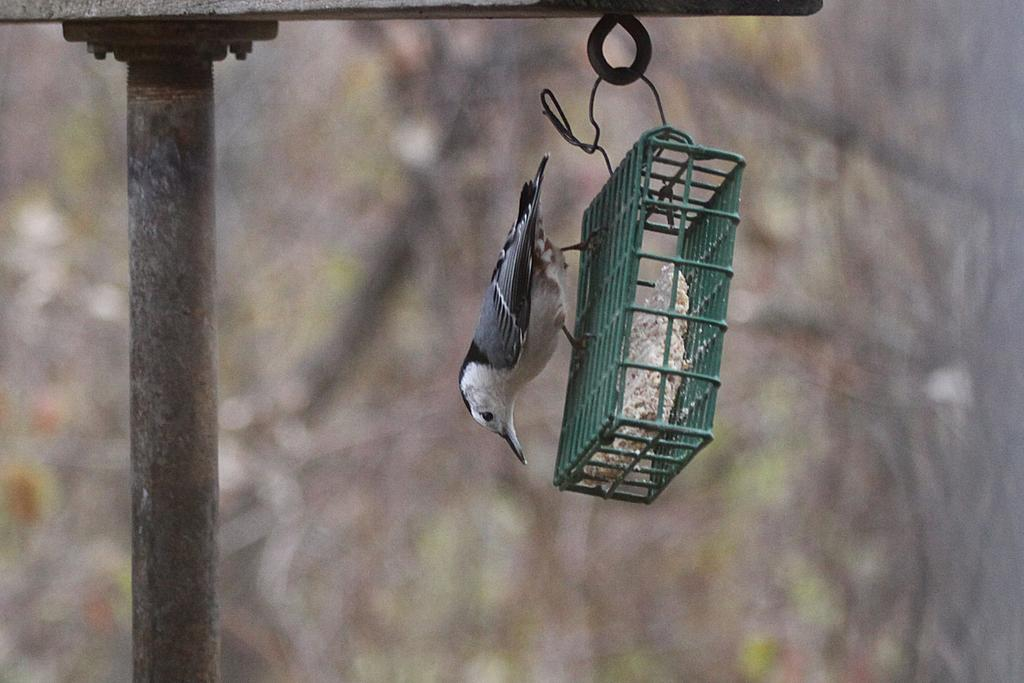What type of animal is present in the image? There is a bird in the image. What is the bird standing on in the image? The bird is standing on a hanger-like object. How is the hanger-like object suspended in the image? The hanger-like object is hanging from a pole. What type of comb does the bird's dad use in the image? There is no mention of a dad or a comb in the image; it features a bird standing on a hanger-like object that is hanging from a pole. 